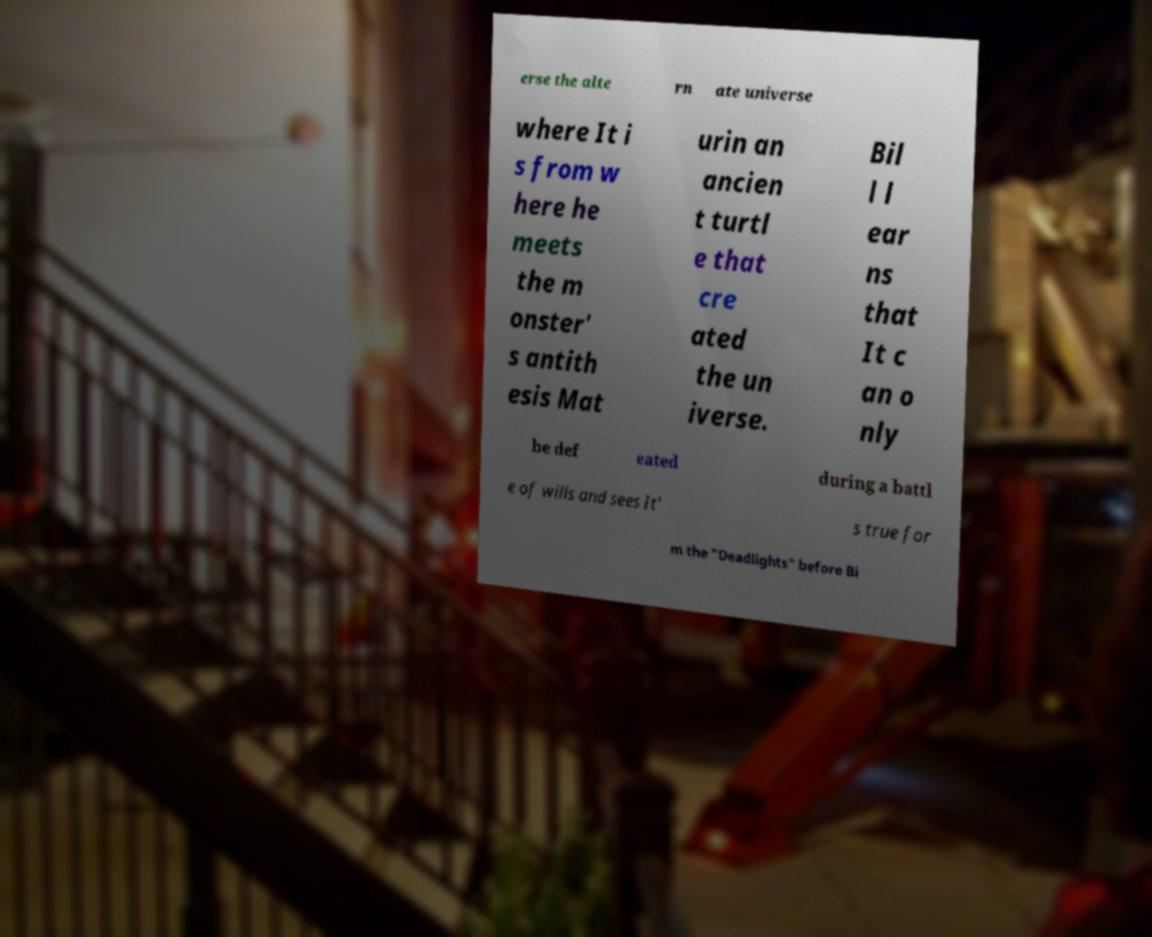For documentation purposes, I need the text within this image transcribed. Could you provide that? erse the alte rn ate universe where It i s from w here he meets the m onster' s antith esis Mat urin an ancien t turtl e that cre ated the un iverse. Bil l l ear ns that It c an o nly be def eated during a battl e of wills and sees It' s true for m the "Deadlights" before Bi 